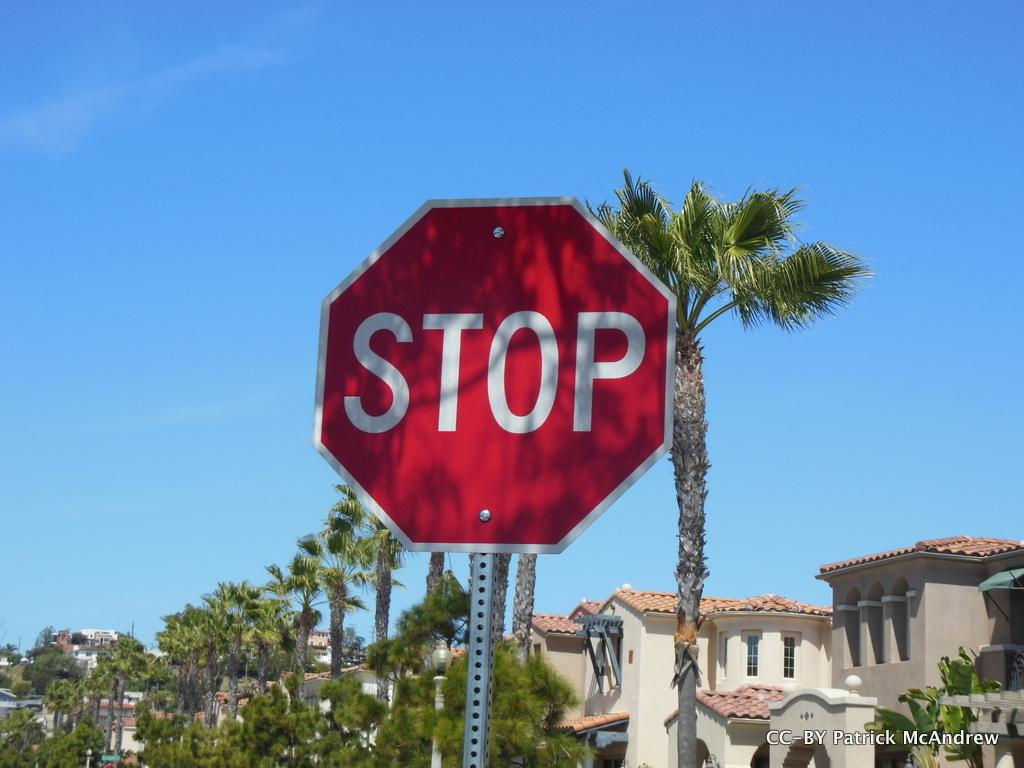<image>
Write a terse but informative summary of the picture. A red stop sign on a street in a neighborhood. 